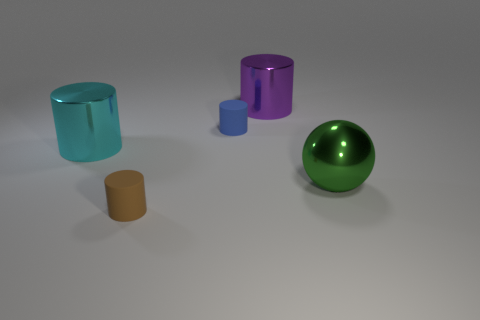What number of tiny yellow shiny cubes are there?
Your answer should be very brief. 0. There is a metallic thing behind the tiny blue matte object; what color is it?
Provide a short and direct response. Purple. The ball is what size?
Provide a short and direct response. Large. Does the ball have the same color as the matte cylinder in front of the big cyan cylinder?
Ensure brevity in your answer.  No. What color is the small rubber thing that is behind the matte cylinder on the left side of the blue matte cylinder?
Ensure brevity in your answer.  Blue. Is there any other thing that has the same size as the green shiny object?
Your answer should be compact. Yes. Does the shiny thing behind the cyan shiny thing have the same shape as the big green shiny thing?
Ensure brevity in your answer.  No. How many objects are both behind the cyan cylinder and right of the small blue cylinder?
Give a very brief answer. 1. There is a large metal object to the left of the big cylinder on the right side of the shiny cylinder that is in front of the purple shiny cylinder; what color is it?
Offer a terse response. Cyan. How many shiny cylinders are right of the small object that is behind the large cyan object?
Your answer should be very brief. 1. 